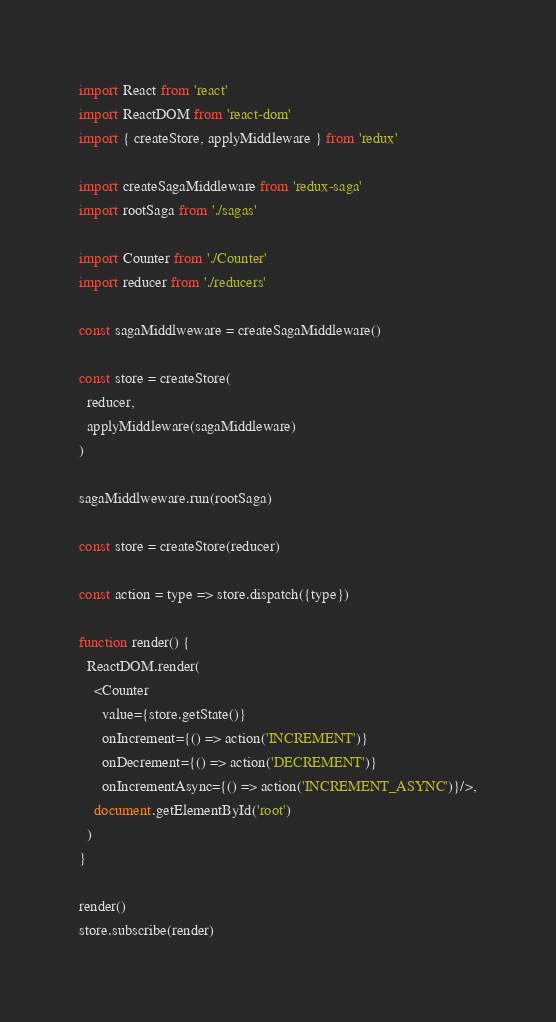<code> <loc_0><loc_0><loc_500><loc_500><_JavaScript_>import React from 'react'
import ReactDOM from 'react-dom'
import { createStore, applyMiddleware } from 'redux'

import createSagaMiddleware from 'redux-saga'
import rootSaga from './sagas'

import Counter from './Counter'
import reducer from './reducers'

const sagaMiddlweware = createSagaMiddleware()

const store = createStore(
  reducer,
  applyMiddleware(sagaMiddleware)
)

sagaMiddlweware.run(rootSaga)

const store = createStore(reducer)

const action = type => store.dispatch({type})

function render() {
  ReactDOM.render(
    <Counter
      value={store.getState()}
      onIncrement={() => action('INCREMENT')}
      onDecrement={() => action('DECREMENT')}
      onIncrementAsync={() => action('INCREMENT_ASYNC')}/>,
    document.getElementById('root')
  )
}

render()
store.subscribe(render)
</code> 